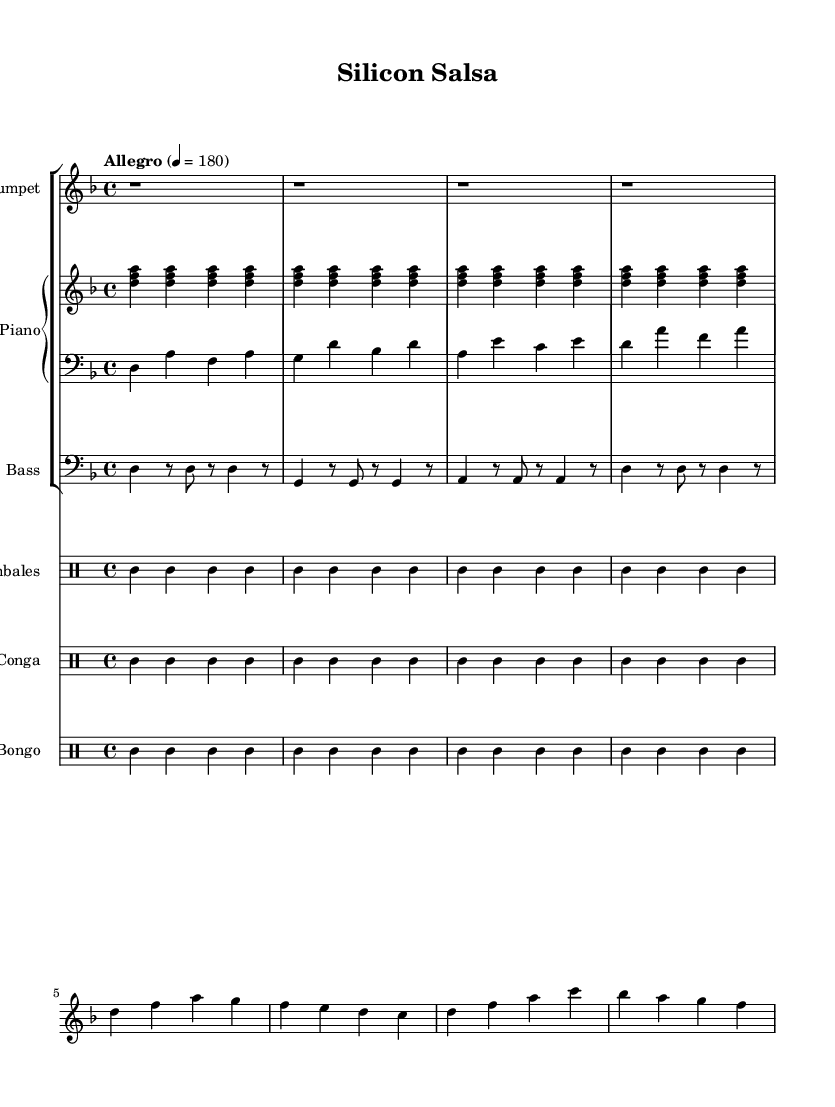What is the key signature of this music? The key signature is D minor, which is indicated by one flat (B♭).
Answer: D minor What is the time signature of the music? The time signature is 4/4, which means there are four beats in each measure.
Answer: 4/4 What is the tempo marking given for this piece? The tempo marking states "Allegro," indicating a fast pace; the metronome marking shows a speed of quarter note = 180 beats per minute.
Answer: Allegro How many measures are there in the trumpet section? By counting the measures represented in the music, there are 8 measures of trumpet music shown.
Answer: 8 Which instruments are playing in the piece? The piece features the Trumpet, Piano (with right and left hands), Bass, Timbales, Conga, and Bongo, totaling six instruments.
Answer: Trumpet, Piano, Bass, Timbales, Conga, Bongo What rhythmic pattern is primarily used in the conga part? The conga section predominantly follows a pattern alternating between high (cgh) and low (cgl) tones, creating a driving rhythm characteristic of Latin music.
Answer: Alternating high and low tones What genre of music is this piece representative of? The piece captures the essence of Salsa, which is a lively genre that incorporates multiple Latin rhythms and is known for its fast tempo and danceable beats.
Answer: Salsa 